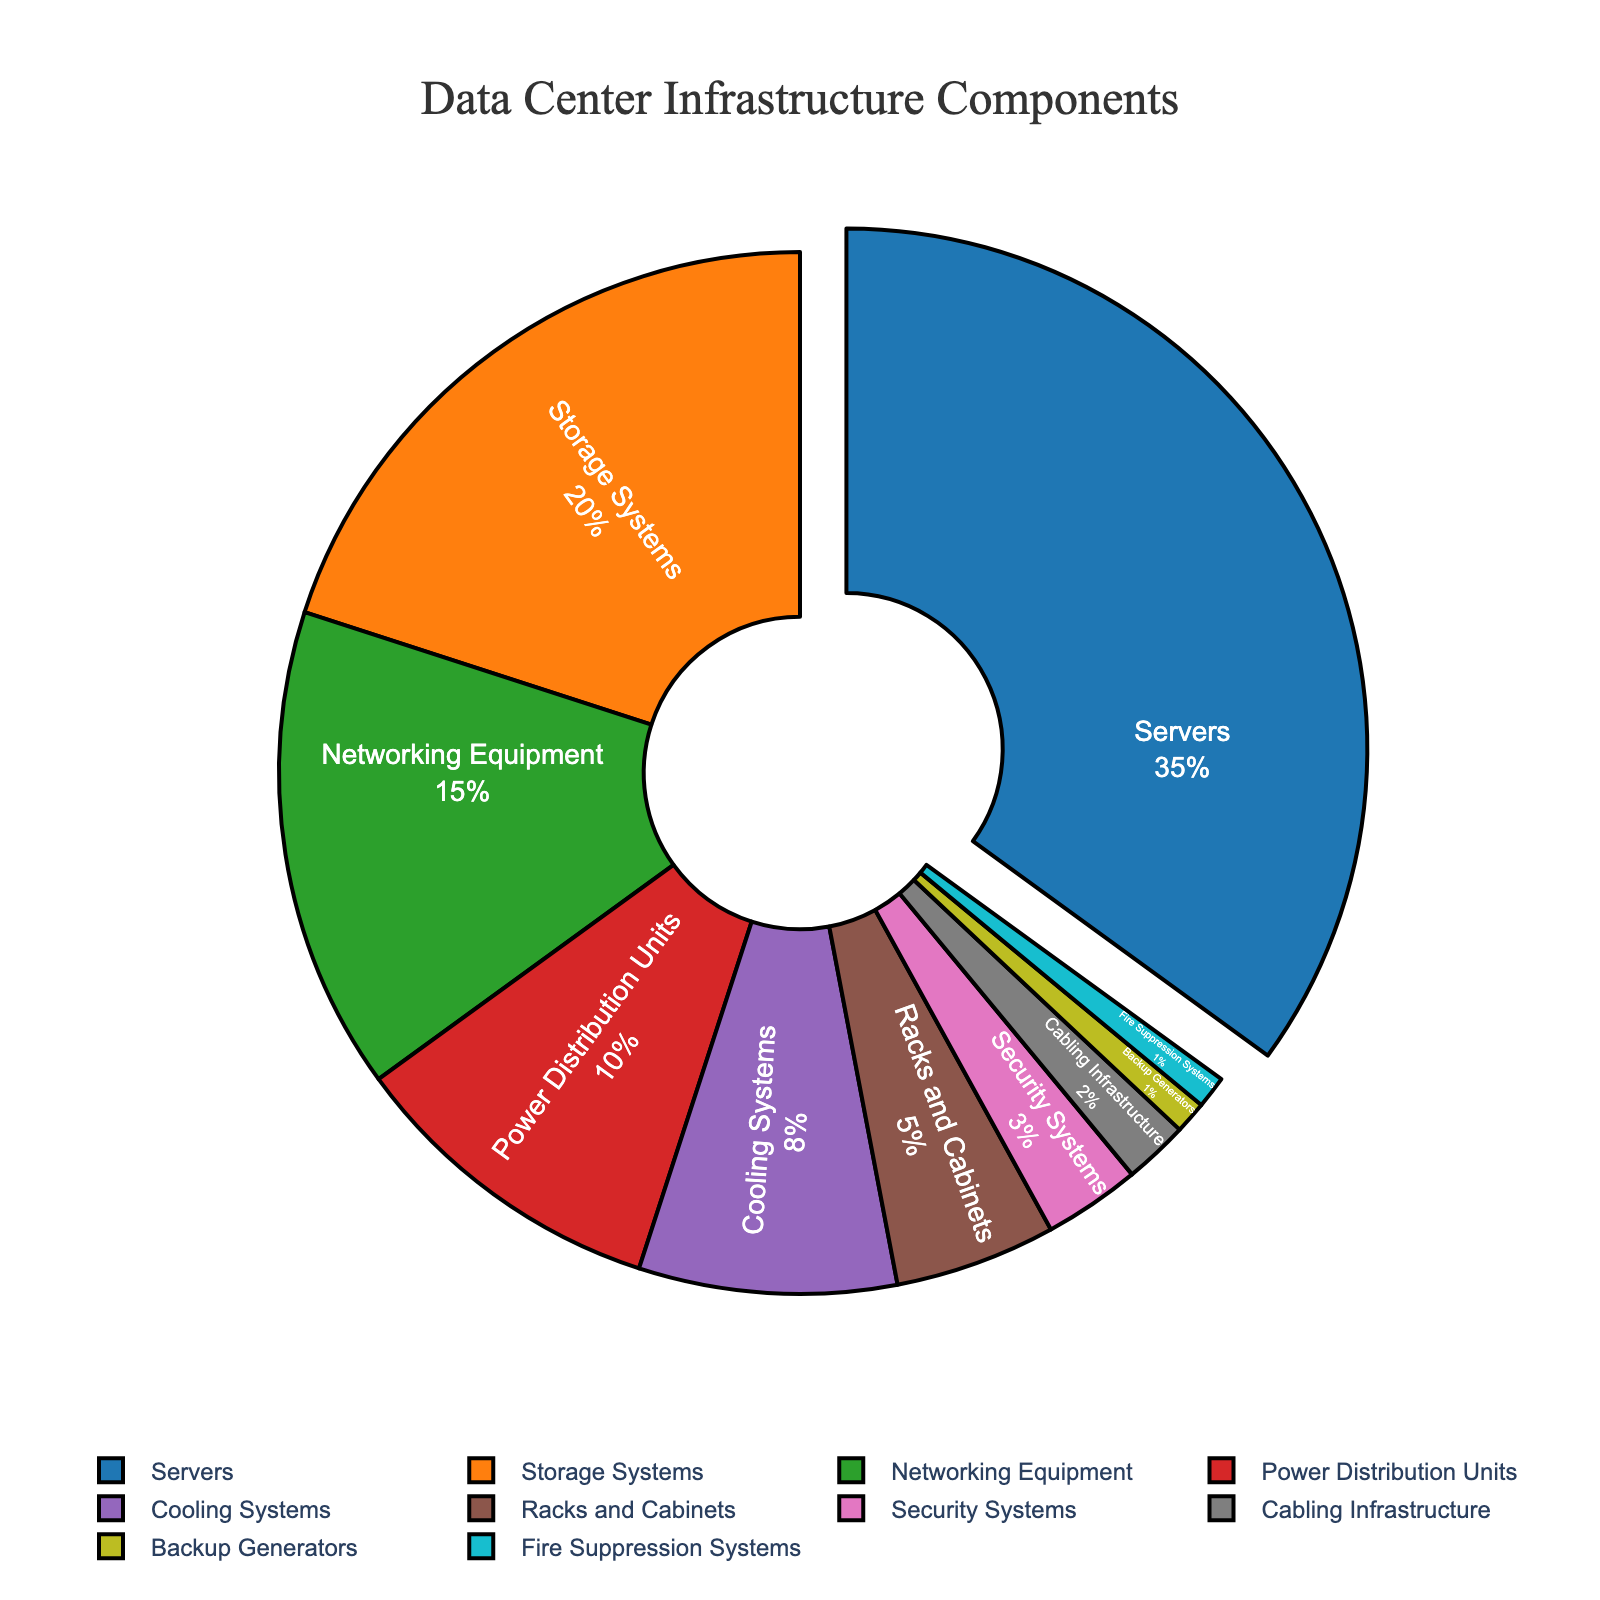What's the largest component in the data center infrastructure? The largest component can be identified by looking at the section of the pie chart that occupies the most space. This is labeled 'Servers'.
Answer: Servers Which three components collectively account for more than half of the data center infrastructure? Adding the percentages of the top three components: Servers (35%), Storage Systems (20%), and Networking Equipment (15%). The total is 35 + 20 + 15 = 70%, which is more than half.
Answer: Servers, Storage Systems, Networking Equipment How much more percentage do Servers have compared to Storage Systems? Subtract the percentage of Storage Systems (20%) from the percentage of Servers (35%). The difference is 35 - 20 = 15%.
Answer: 15% Which component has the smallest percentage in the data center infrastructure and what is its value? The smallest section of the pie chart, labeled 'Backup Generators' and 'Fire Suppression Systems', both have 1%.
Answer: Backup Generators, Fire Suppression Systems Are there any components in the chart that have equal percentages? Yes, the pie chart shows that 'Backup Generators' and 'Fire Suppression Systems' each have 1%.
Answer: Yes, Backup Generators and Fire Suppression Systems Which security-related component has a higher percentage, Security Systems or Fire Suppression Systems? The pie chart indicates that 'Security Systems' have 3%, while 'Fire Suppression Systems' have 1%.
Answer: Security Systems What is the combined percentage of Power Distribution Units and Cooling Systems? Add the percentages of Power Distribution Units (10%) and Cooling Systems (8%). The total is 10 + 8 = 18%.
Answer: 18% Between Networking Equipment and Cooling Systems, which has a larger percentage and by how much? Networking Equipment has 15%, and Cooling Systems have 8%. Subtracting these, 15 - 8 = 7%.
Answer: Networking Equipment, by 7% What is the percentage difference between Racks and Cabinets and Cabling Infrastructure? Racks and Cabinets have 5%, while Cabling Infrastructure has 2%. The difference is 5 - 2 = 3%.
Answer: 3% Which components are shown in shades of brown and what are their percentages? The pie chart uses different shades for components, with Racks and Cabinets (5%) and Security Systems (3%) shown in shades of brown.
Answer: Racks and Cabinets (5%), Security Systems (3%) 